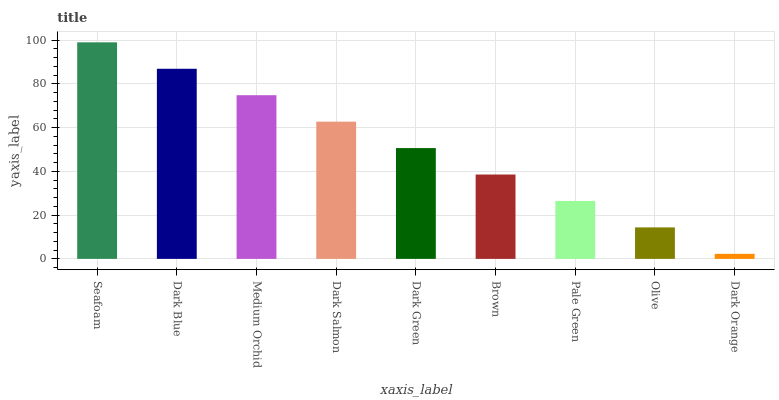Is Dark Orange the minimum?
Answer yes or no. Yes. Is Seafoam the maximum?
Answer yes or no. Yes. Is Dark Blue the minimum?
Answer yes or no. No. Is Dark Blue the maximum?
Answer yes or no. No. Is Seafoam greater than Dark Blue?
Answer yes or no. Yes. Is Dark Blue less than Seafoam?
Answer yes or no. Yes. Is Dark Blue greater than Seafoam?
Answer yes or no. No. Is Seafoam less than Dark Blue?
Answer yes or no. No. Is Dark Green the high median?
Answer yes or no. Yes. Is Dark Green the low median?
Answer yes or no. Yes. Is Dark Blue the high median?
Answer yes or no. No. Is Dark Blue the low median?
Answer yes or no. No. 